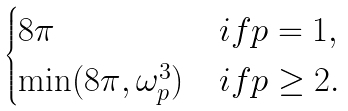<formula> <loc_0><loc_0><loc_500><loc_500>\begin{cases} 8 \pi & i f p = 1 , \\ \min ( 8 \pi , \omega ^ { 3 } _ { p } ) & i f p \geq 2 . \end{cases}</formula> 